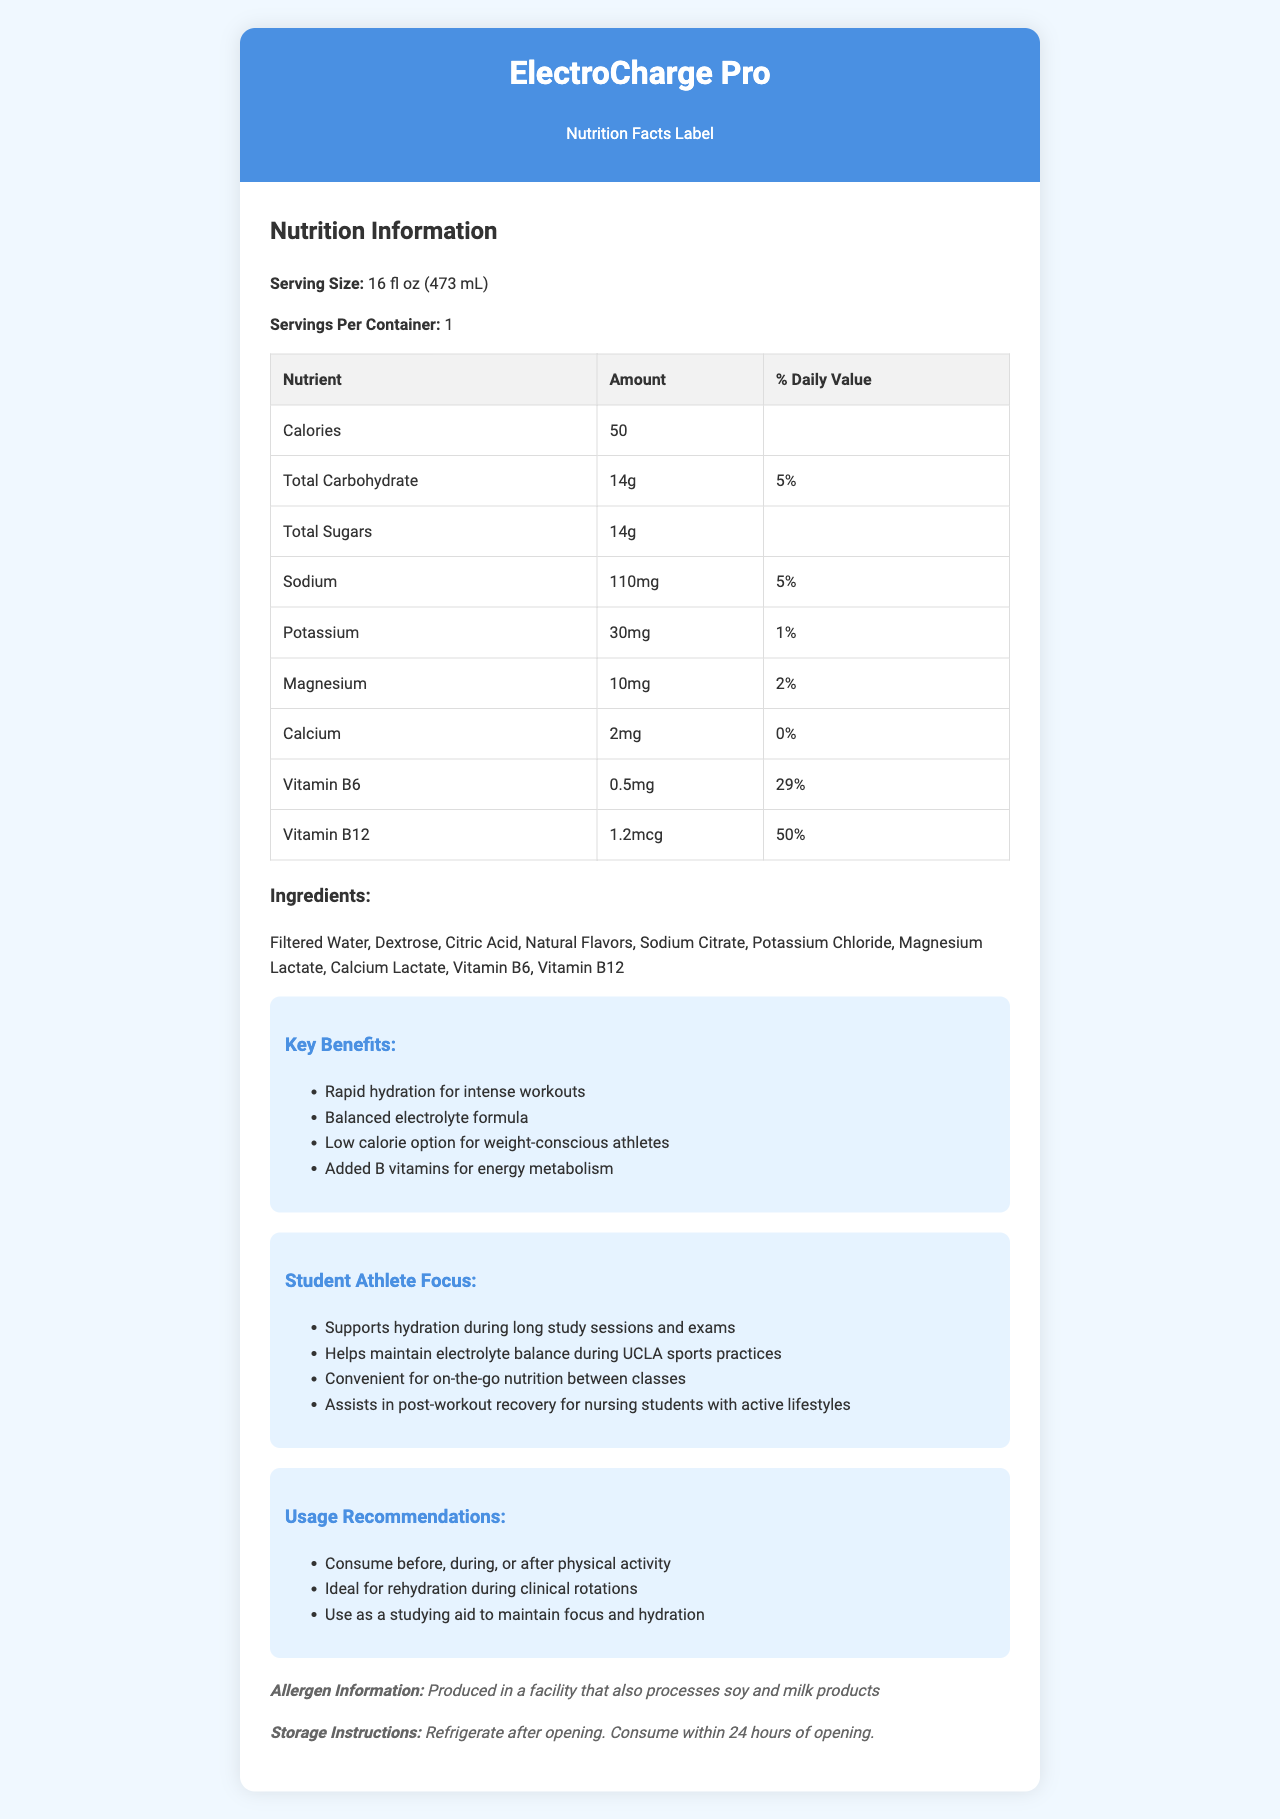what is the serving size of ElectroCharge Pro? The document lists the serving size of ElectroCharge Pro as 16 fl oz (473 mL).
Answer: 16 fl oz (473 mL) What is the amount of sodium per serving? The document states that there are 110mg of sodium per serving.
Answer: 110mg What percentage of the daily value is provided by the potassium content? The potassium content provides 1% of the daily value as per the document.
Answer: 1% How much Vitamin B6 is in one serving? The nutrition label shows that one serving contains 0.5mg of Vitamin B6.
Answer: 0.5mg How many grams of total carbohydrates are in one serving? The total carbohydrate content per serving is 14g according to the document.
Answer: 14g Which electrolyte has the highest daily value percentage in ElectroCharge Pro? A. Sodium B. Potassium C. Magnesium D. Calcium Sodium has a daily value percentage of 5%, which is the highest among the electrolytes listed.
Answer: A. Sodium What is the daily value percentage for Vitamin B12 in each serving? A. 29% B. 50% C. 10% D. 5% The daily value percentage for Vitamin B12 is listed as 50%.
Answer: B. 50% Does ElectroCharge Pro help with studying and maintaining focus? Yes/No The document mentions that ElectroCharge Pro can be used as a studying aid to maintain focus and hydration.
Answer: Yes Summarize the main benefits of ElectroCharge Pro. The benefits section in the document enumerates multiple advantages such as rapid hydration, a balanced electrolyte formula, low calorie, added B vitamins for energy metabolism, and specific uses for student athletes including studying aid and post-workout recovery.
Answer: ElectroCharge Pro offers rapid hydration for intense workouts, a balanced electrolyte formula, low calorie option for weight-conscious athletes, and added B vitamins for energy metabolism. It also supports hydration during long study sessions and exams, helps maintain electrolyte balance during sports practices, and assists in post-workout recovery for active nursing students. What types of products does the facility that manufactures ElectroCharge Pro also process? The allergen information states that the product is produced in a facility that also processes soy and milk products.
Answer: Soy and milk products What is the recommended usage of ElectroCharge Pro during clinical rotations? The usage recommendations specify that the product is ideal for rehydration during clinical rotations.
Answer: Ideal for rehydration What is the cost of ElectroCharge Pro? The document does not provide any information regarding the cost of ElectroCharge Pro.
Answer: Cannot be determined 